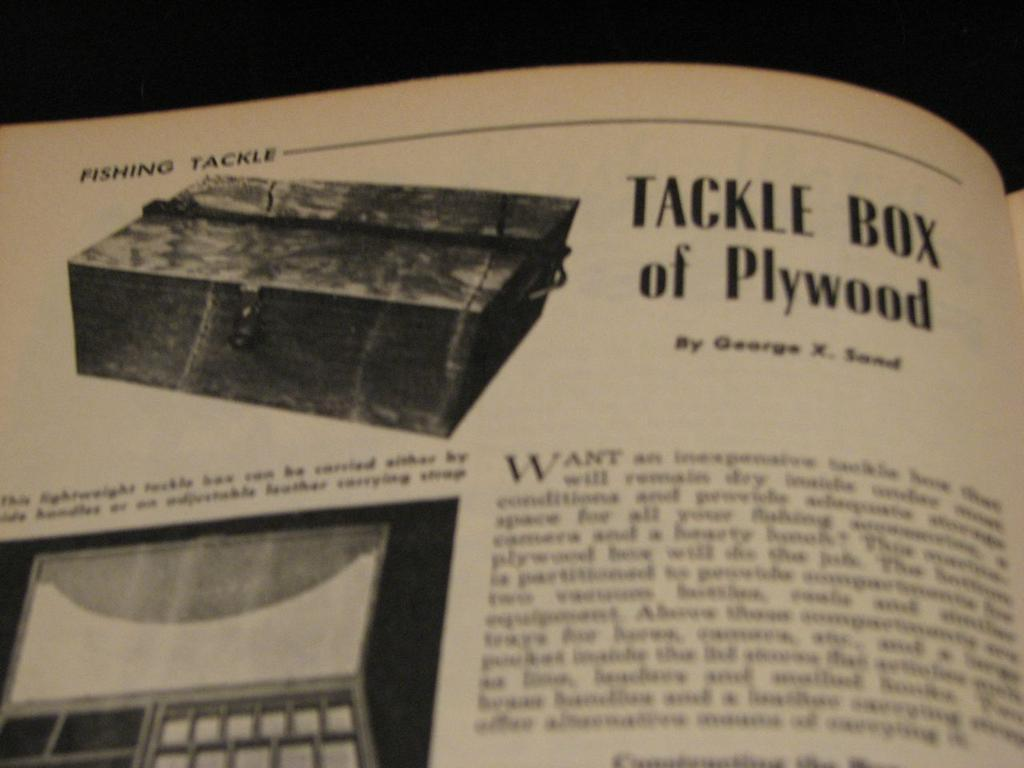<image>
Write a terse but informative summary of the picture. An article talks about tackle boxes made of plywood. 